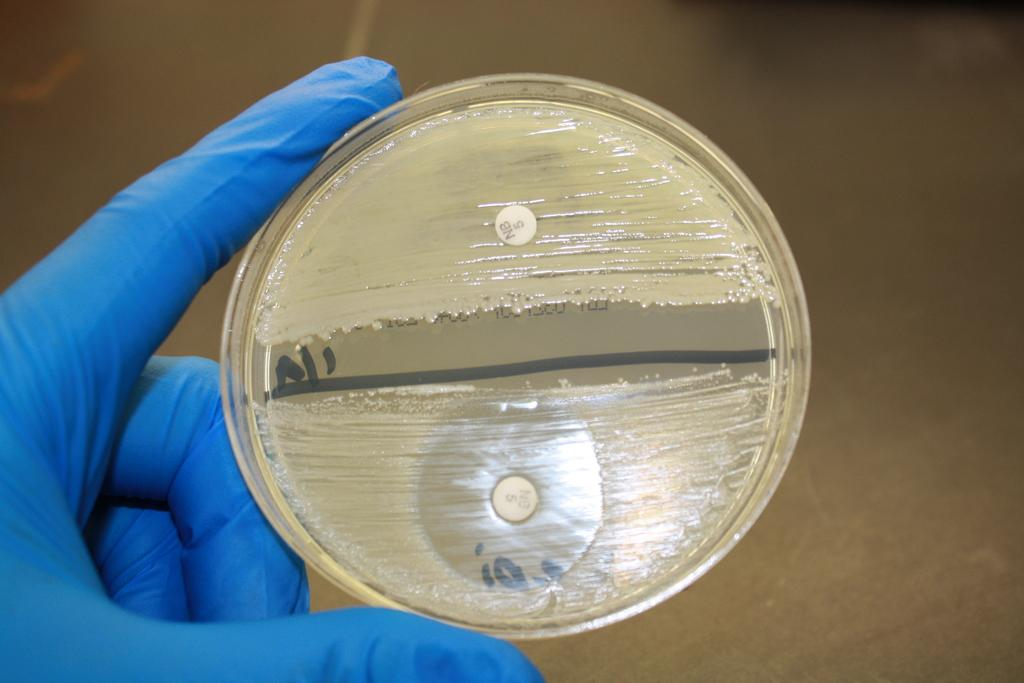What is the focus of the image? The image is zoomed in, focusing on a person's hand. What can be observed about the hand in the image? The hand is wearing a blue glove. What is the hand holding in the image? The hand is holding an object. What can be seen in the background of the image? The background appears to be the ground. What type of pear is being placed in the basket in the image? There is no pear or basket present in the image; it features a person's hand wearing a blue glove and holding an object. 